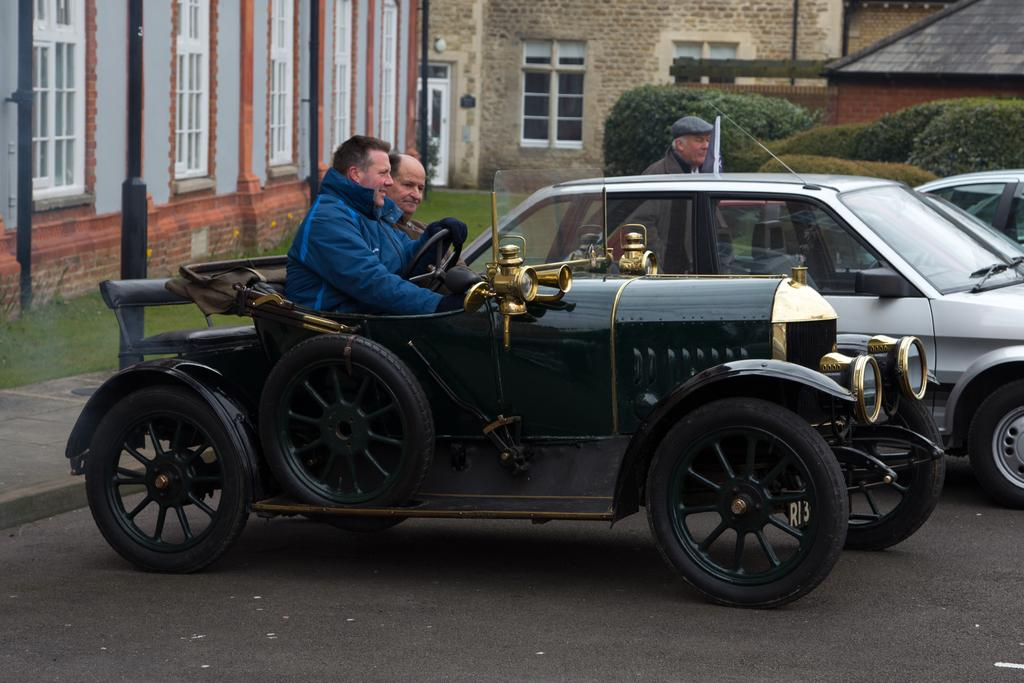What vehicle is present in the image? There is a jeep in the image. Who is inside the jeep? Two persons are sitting in the jeep. What other vehicles can be seen in the image? There are cars in the image. What is visible in the background of the image? There are buildings with windows in the background. What type of vegetation is present on the ground? There is grass on the ground. Are there any other plants visible in the image? Yes, there are bushes in the image. What type of toothpaste is being used to clean the windows of the buildings in the image? There is no toothpaste present in the image, and the windows of the buildings are not being cleaned. 